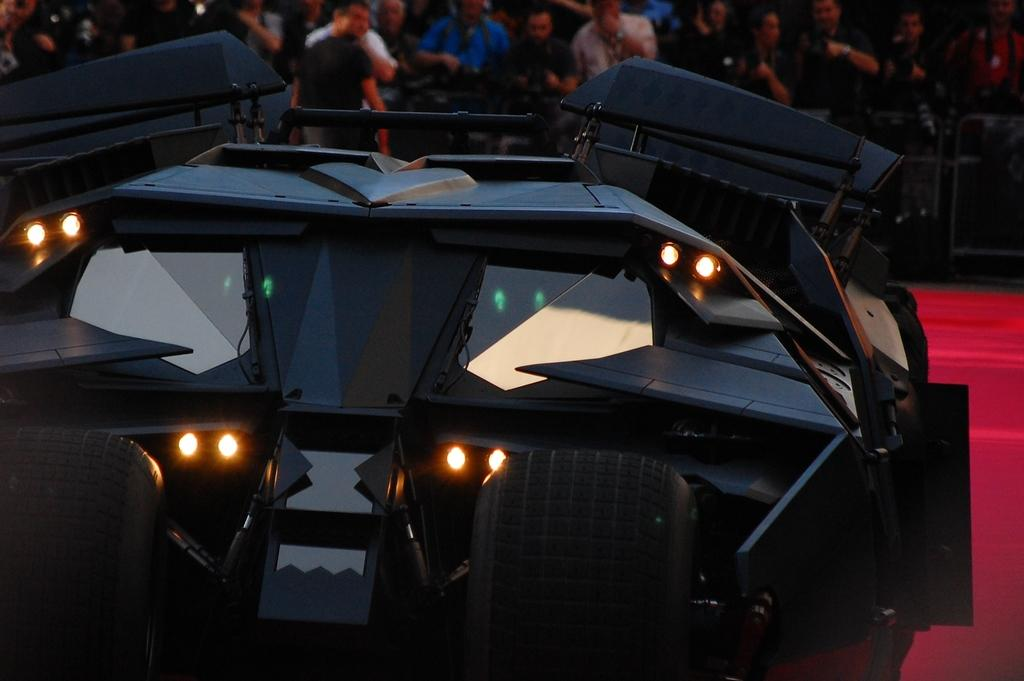What is the main subject of the image? The main subject of the image is a vehicle. What feature does the vehicle have? The vehicle has lights. What else can be seen in the image besides the vehicle? There are people standing in the image. What are the people wearing? The people are wearing clothes. How would you describe the background of the image? The background of the image is blurred. How many cakes are being served at the event in the image? There is no event or cakes present in the image; it features a vehicle with lights and people standing nearby. What type of sheet is covering the vehicle in the image? There is no sheet covering the vehicle in the image; it is visible with its lights on. 